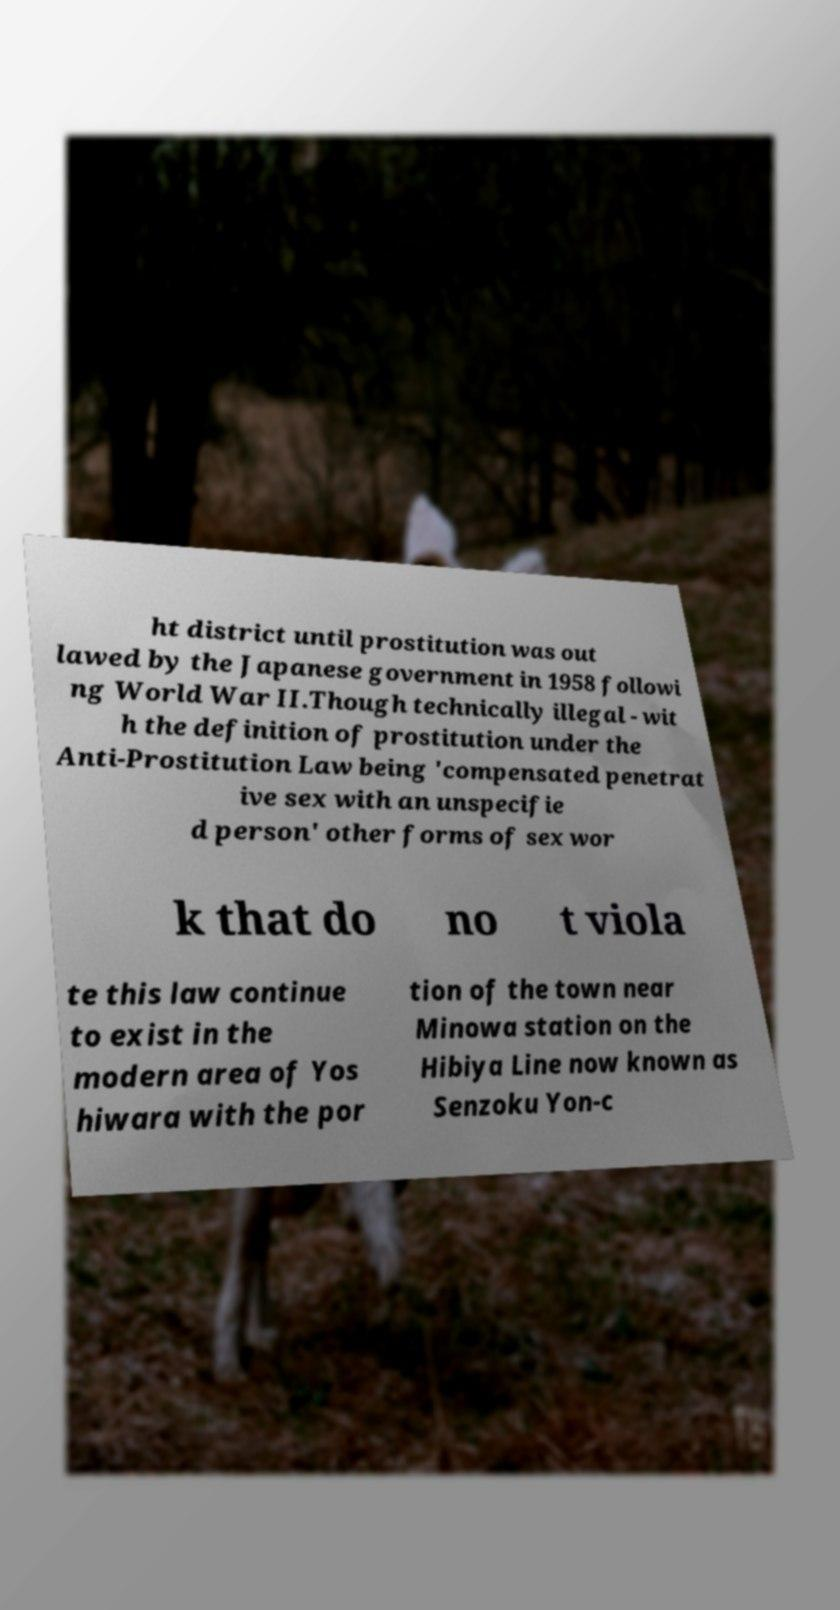For documentation purposes, I need the text within this image transcribed. Could you provide that? ht district until prostitution was out lawed by the Japanese government in 1958 followi ng World War II.Though technically illegal - wit h the definition of prostitution under the Anti-Prostitution Law being 'compensated penetrat ive sex with an unspecifie d person' other forms of sex wor k that do no t viola te this law continue to exist in the modern area of Yos hiwara with the por tion of the town near Minowa station on the Hibiya Line now known as Senzoku Yon-c 